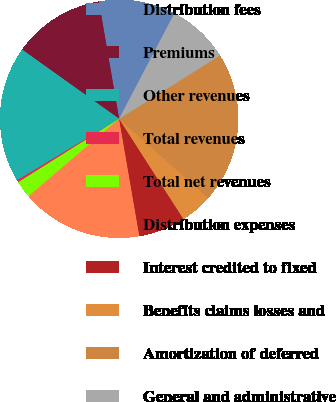<chart> <loc_0><loc_0><loc_500><loc_500><pie_chart><fcel>Distribution fees<fcel>Premiums<fcel>Other revenues<fcel>Total revenues<fcel>Total net revenues<fcel>Distribution expenses<fcel>Interest credited to fixed<fcel>Benefits claims losses and<fcel>Amortization of deferred<fcel>General and administrative<nl><fcel>10.4%<fcel>12.42%<fcel>18.48%<fcel>0.31%<fcel>2.33%<fcel>16.46%<fcel>6.36%<fcel>4.35%<fcel>20.5%<fcel>8.38%<nl></chart> 